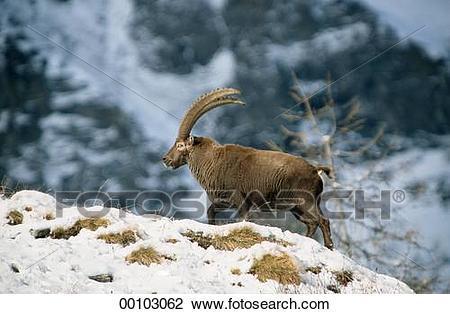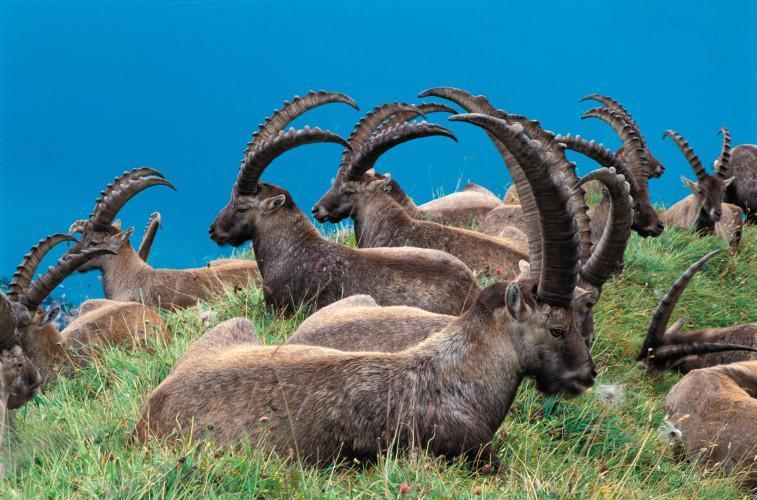The first image is the image on the left, the second image is the image on the right. Given the left and right images, does the statement "There are at least two goats and none of them are on the grass." hold true? Answer yes or no. No. The first image is the image on the left, the second image is the image on the right. Considering the images on both sides, is "the sky is visible in the image on the right" valid? Answer yes or no. Yes. 